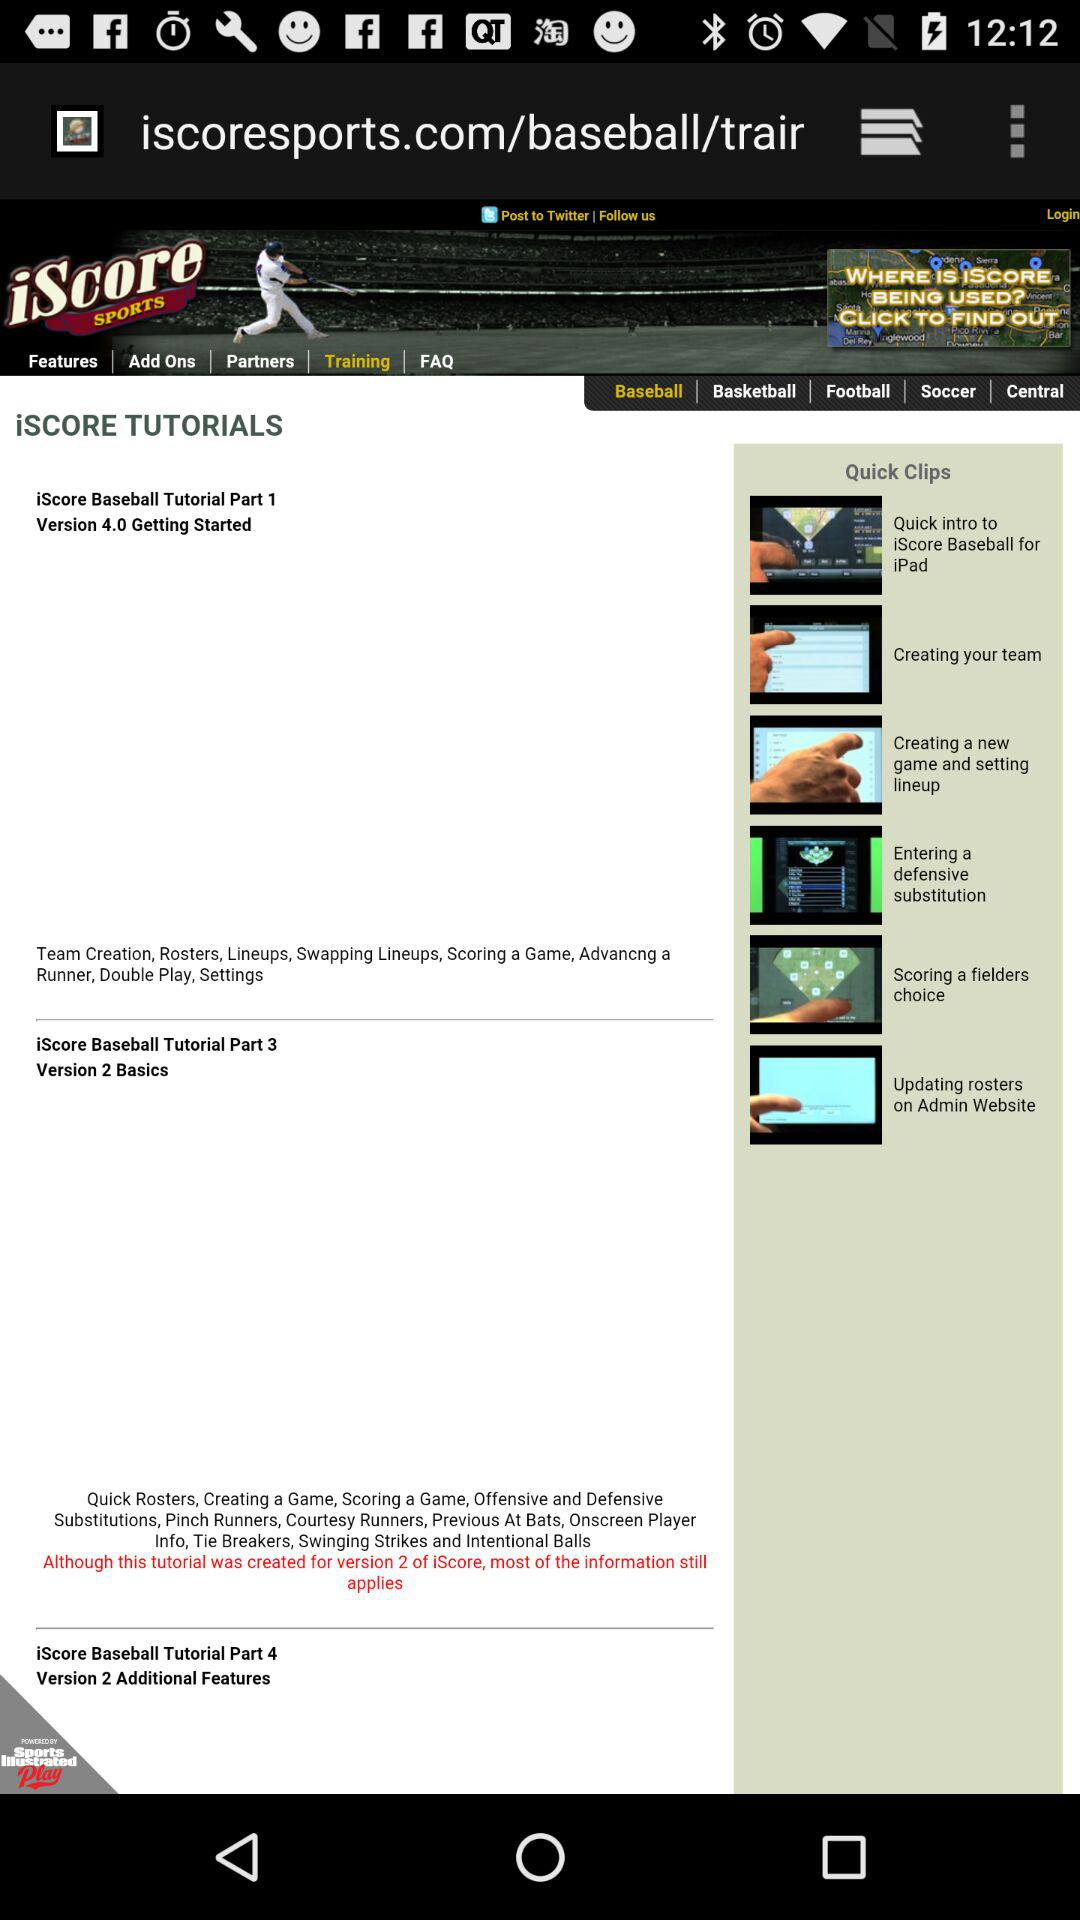In which part of the iScore Baseball tutorial are there additional features? There are additional features in Part 4. 